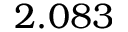<formula> <loc_0><loc_0><loc_500><loc_500>2 . 0 8 3</formula> 